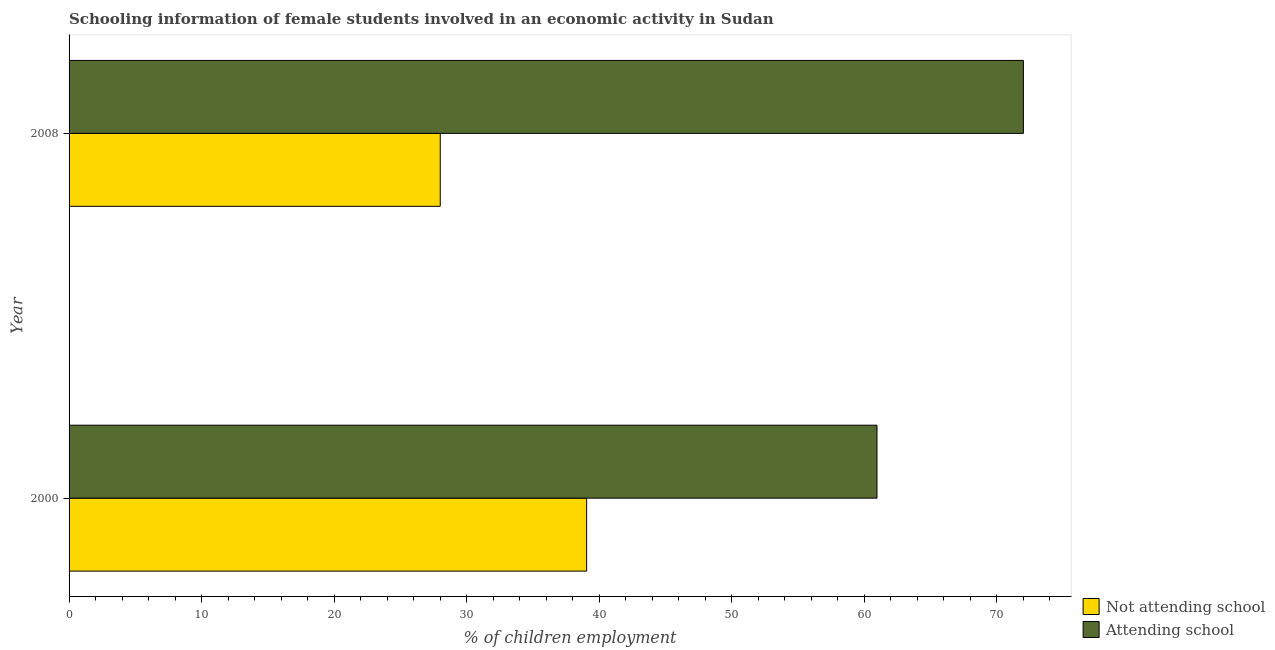Are the number of bars on each tick of the Y-axis equal?
Keep it short and to the point. Yes. How many bars are there on the 2nd tick from the top?
Provide a succinct answer. 2. How many bars are there on the 2nd tick from the bottom?
Give a very brief answer. 2. In how many cases, is the number of bars for a given year not equal to the number of legend labels?
Ensure brevity in your answer.  0. What is the percentage of employed females who are not attending school in 2008?
Give a very brief answer. 28. Across all years, what is the maximum percentage of employed females who are attending school?
Your answer should be very brief. 72. Across all years, what is the minimum percentage of employed females who are attending school?
Your answer should be very brief. 60.95. In which year was the percentage of employed females who are attending school maximum?
Make the answer very short. 2008. In which year was the percentage of employed females who are not attending school minimum?
Keep it short and to the point. 2008. What is the total percentage of employed females who are not attending school in the graph?
Provide a succinct answer. 67.05. What is the difference between the percentage of employed females who are attending school in 2000 and that in 2008?
Give a very brief answer. -11.04. What is the difference between the percentage of employed females who are not attending school in 2000 and the percentage of employed females who are attending school in 2008?
Your answer should be very brief. -32.95. What is the average percentage of employed females who are not attending school per year?
Ensure brevity in your answer.  33.52. In the year 2008, what is the difference between the percentage of employed females who are attending school and percentage of employed females who are not attending school?
Offer a very short reply. 43.99. In how many years, is the percentage of employed females who are not attending school greater than 32 %?
Offer a terse response. 1. What is the ratio of the percentage of employed females who are attending school in 2000 to that in 2008?
Make the answer very short. 0.85. What does the 2nd bar from the top in 2008 represents?
Give a very brief answer. Not attending school. What does the 2nd bar from the bottom in 2008 represents?
Your response must be concise. Attending school. How many years are there in the graph?
Ensure brevity in your answer.  2. What is the difference between two consecutive major ticks on the X-axis?
Give a very brief answer. 10. How many legend labels are there?
Your answer should be compact. 2. What is the title of the graph?
Your answer should be very brief. Schooling information of female students involved in an economic activity in Sudan. What is the label or title of the X-axis?
Make the answer very short. % of children employment. What is the % of children employment of Not attending school in 2000?
Your response must be concise. 39.05. What is the % of children employment of Attending school in 2000?
Your answer should be very brief. 60.95. What is the % of children employment in Not attending school in 2008?
Give a very brief answer. 28. What is the % of children employment of Attending school in 2008?
Give a very brief answer. 72. Across all years, what is the maximum % of children employment of Not attending school?
Keep it short and to the point. 39.05. Across all years, what is the maximum % of children employment in Attending school?
Offer a very short reply. 72. Across all years, what is the minimum % of children employment in Not attending school?
Your answer should be compact. 28. Across all years, what is the minimum % of children employment of Attending school?
Offer a terse response. 60.95. What is the total % of children employment in Not attending school in the graph?
Ensure brevity in your answer.  67.05. What is the total % of children employment of Attending school in the graph?
Make the answer very short. 132.95. What is the difference between the % of children employment of Not attending school in 2000 and that in 2008?
Offer a terse response. 11.04. What is the difference between the % of children employment of Attending school in 2000 and that in 2008?
Offer a terse response. -11.04. What is the difference between the % of children employment of Not attending school in 2000 and the % of children employment of Attending school in 2008?
Make the answer very short. -32.95. What is the average % of children employment in Not attending school per year?
Offer a terse response. 33.52. What is the average % of children employment in Attending school per year?
Your answer should be compact. 66.48. In the year 2000, what is the difference between the % of children employment of Not attending school and % of children employment of Attending school?
Your answer should be very brief. -21.91. In the year 2008, what is the difference between the % of children employment in Not attending school and % of children employment in Attending school?
Ensure brevity in your answer.  -43.99. What is the ratio of the % of children employment of Not attending school in 2000 to that in 2008?
Ensure brevity in your answer.  1.39. What is the ratio of the % of children employment of Attending school in 2000 to that in 2008?
Offer a terse response. 0.85. What is the difference between the highest and the second highest % of children employment in Not attending school?
Offer a terse response. 11.04. What is the difference between the highest and the second highest % of children employment in Attending school?
Make the answer very short. 11.04. What is the difference between the highest and the lowest % of children employment of Not attending school?
Your answer should be very brief. 11.04. What is the difference between the highest and the lowest % of children employment in Attending school?
Offer a terse response. 11.04. 